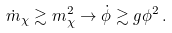<formula> <loc_0><loc_0><loc_500><loc_500>\dot { m } _ { \chi } \gtrsim m ^ { 2 } _ { \chi } \to \dot { \phi } \gtrsim g \phi ^ { 2 } \, .</formula> 